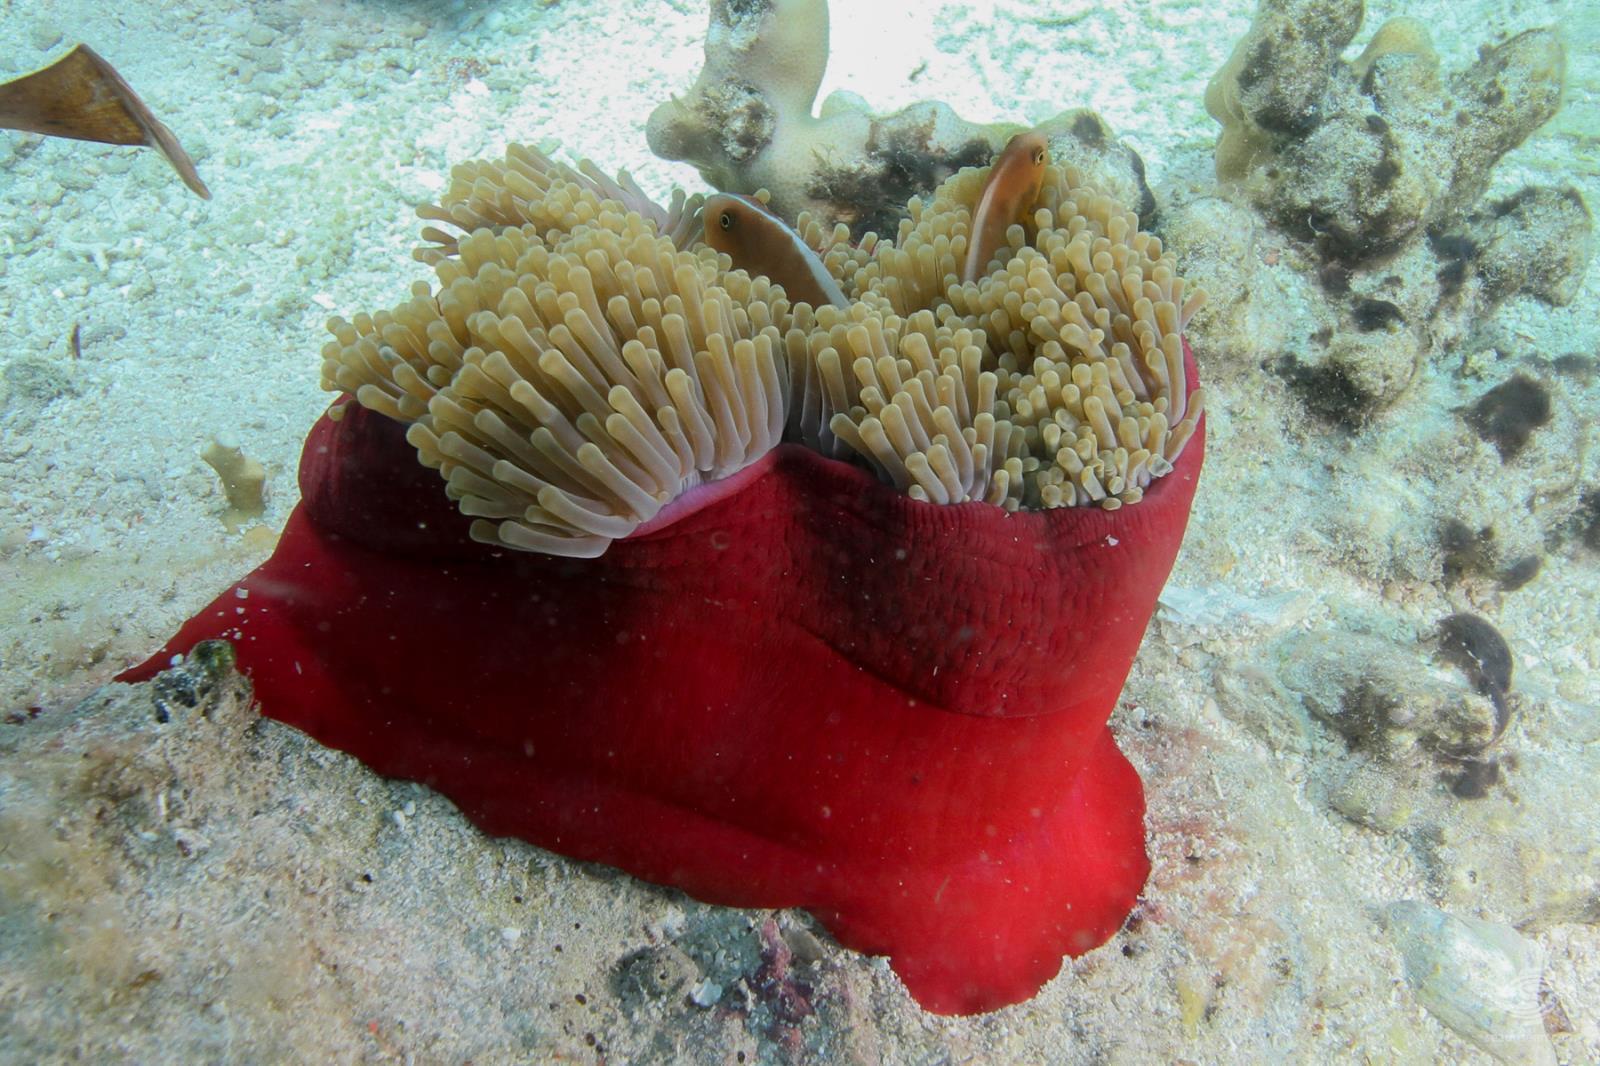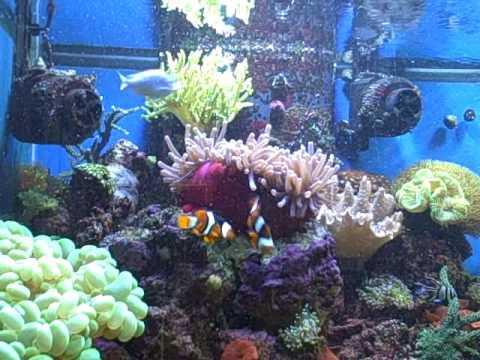The first image is the image on the left, the second image is the image on the right. Analyze the images presented: Is the assertion "A bright yellow fish is swimming in the water in the image on the left." valid? Answer yes or no. No. The first image is the image on the left, the second image is the image on the right. Considering the images on both sides, is "Only one of the images contains clown fish." valid? Answer yes or no. Yes. 